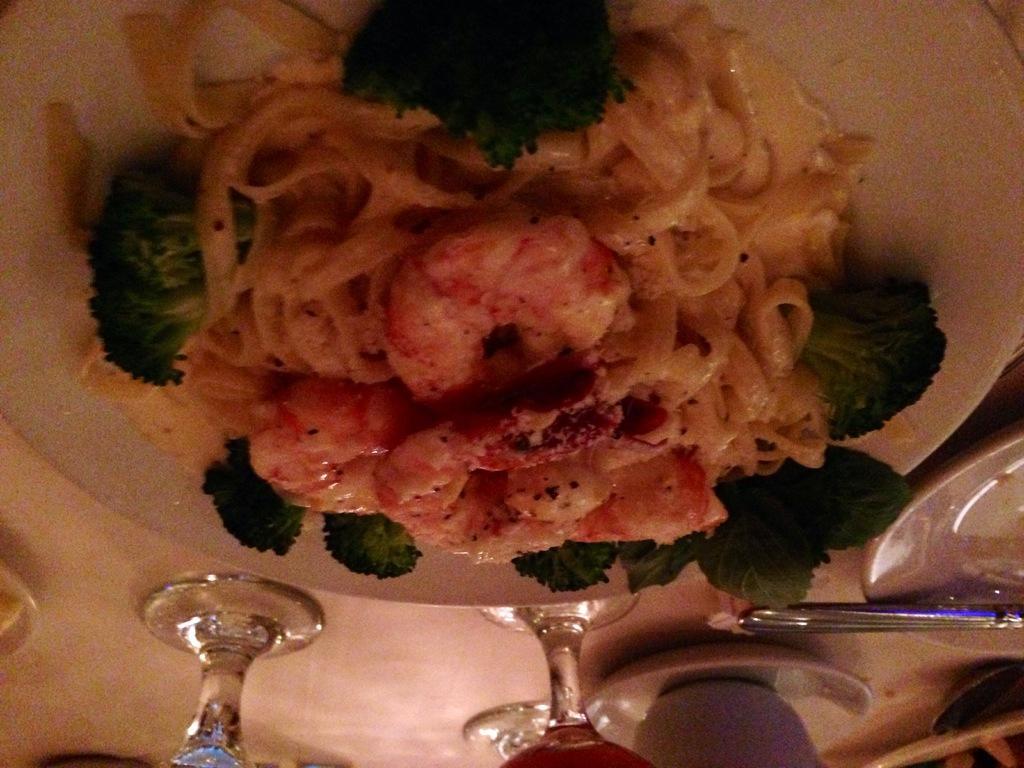Describe this image in one or two sentences. In this image we can see a plate which consists of food items in it and at the bottom of the image there are glass, cups and a few other objects. 